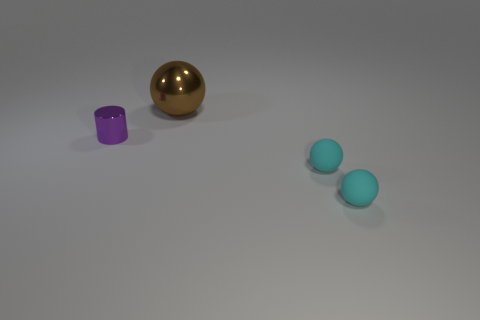Is the thing that is to the left of the brown ball made of the same material as the thing behind the tiny shiny thing?
Keep it short and to the point. Yes. There is a metal object in front of the large shiny object; what shape is it?
Offer a terse response. Cylinder. Are there fewer big brown metallic objects than brown matte balls?
Keep it short and to the point. No. Is there a small thing to the left of the shiny object that is behind the shiny object that is on the left side of the large metal sphere?
Give a very brief answer. Yes. What number of shiny things are yellow spheres or small purple things?
Keep it short and to the point. 1. There is a small purple cylinder; what number of tiny objects are in front of it?
Provide a succinct answer. 2. How many things are in front of the metallic ball and to the right of the shiny cylinder?
Provide a short and direct response. 2. What shape is the tiny purple thing that is made of the same material as the big brown sphere?
Keep it short and to the point. Cylinder. There is a object that is behind the tiny purple shiny object; is its size the same as the object left of the big brown sphere?
Give a very brief answer. No. There is a thing that is to the left of the large shiny object; what is its color?
Your answer should be very brief. Purple. 